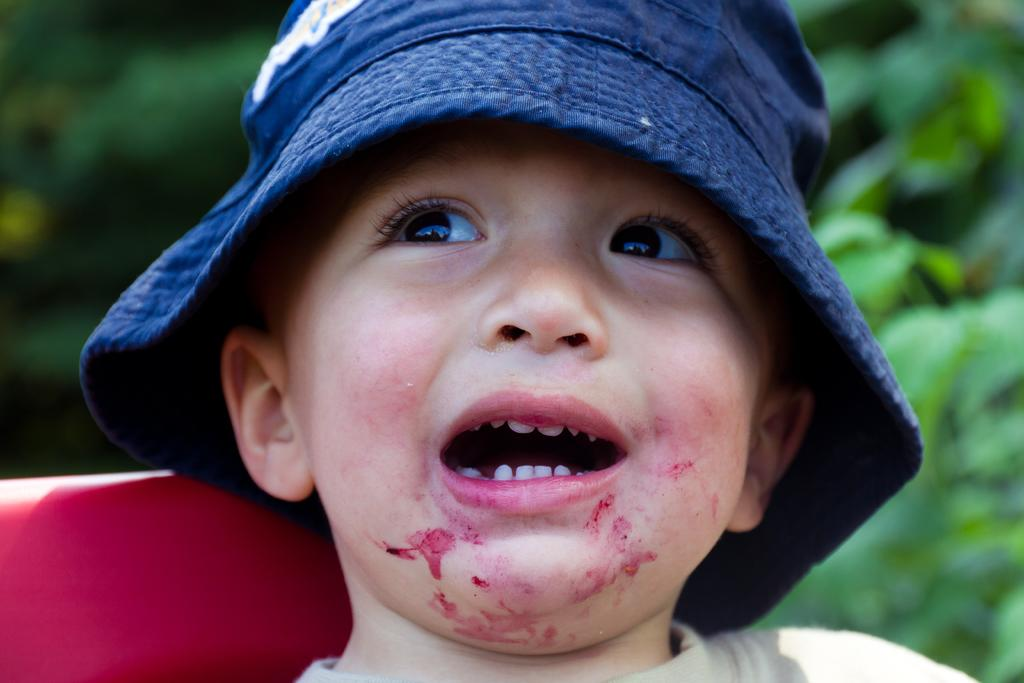Who is the main subject in the image? There is a boy in the image. What is the boy wearing on his head? The boy is wearing a hat. Can you describe the background of the image? The background of the image appears green and blurred. Is there anything else visible in the background besides the green and blurred scenery? There may be an unidentified object in the background. Can you tell me how many roses are being pushed by the boy in the image? There are no roses or any indication of pushing in the image; it features a boy wearing a hat with a green and blurred background. 